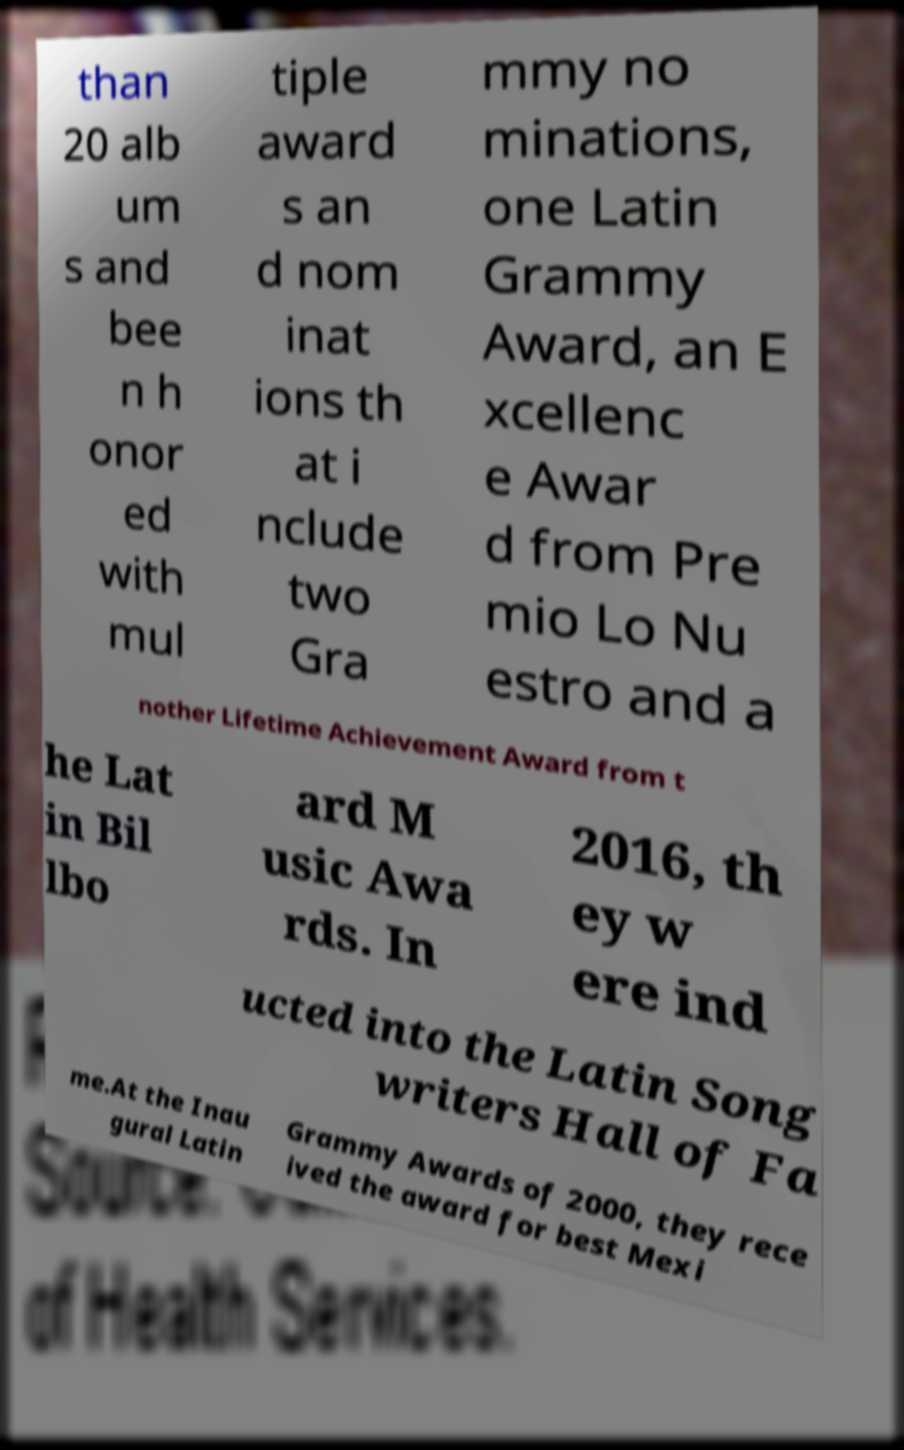For documentation purposes, I need the text within this image transcribed. Could you provide that? than 20 alb um s and bee n h onor ed with mul tiple award s an d nom inat ions th at i nclude two Gra mmy no minations, one Latin Grammy Award, an E xcellenc e Awar d from Pre mio Lo Nu estro and a nother Lifetime Achievement Award from t he Lat in Bil lbo ard M usic Awa rds. In 2016, th ey w ere ind ucted into the Latin Song writers Hall of Fa me.At the Inau gural Latin Grammy Awards of 2000, they rece ived the award for best Mexi 